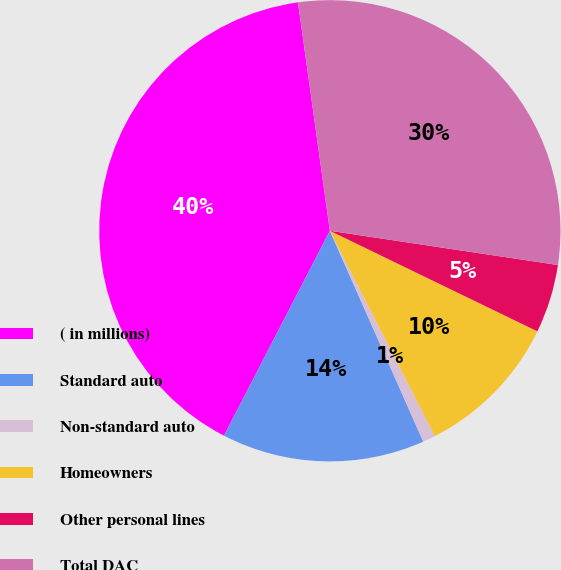Convert chart to OTSL. <chart><loc_0><loc_0><loc_500><loc_500><pie_chart><fcel>( in millions)<fcel>Standard auto<fcel>Non-standard auto<fcel>Homeowners<fcel>Other personal lines<fcel>Total DAC<nl><fcel>40.2%<fcel>14.23%<fcel>0.88%<fcel>10.3%<fcel>4.81%<fcel>29.58%<nl></chart> 